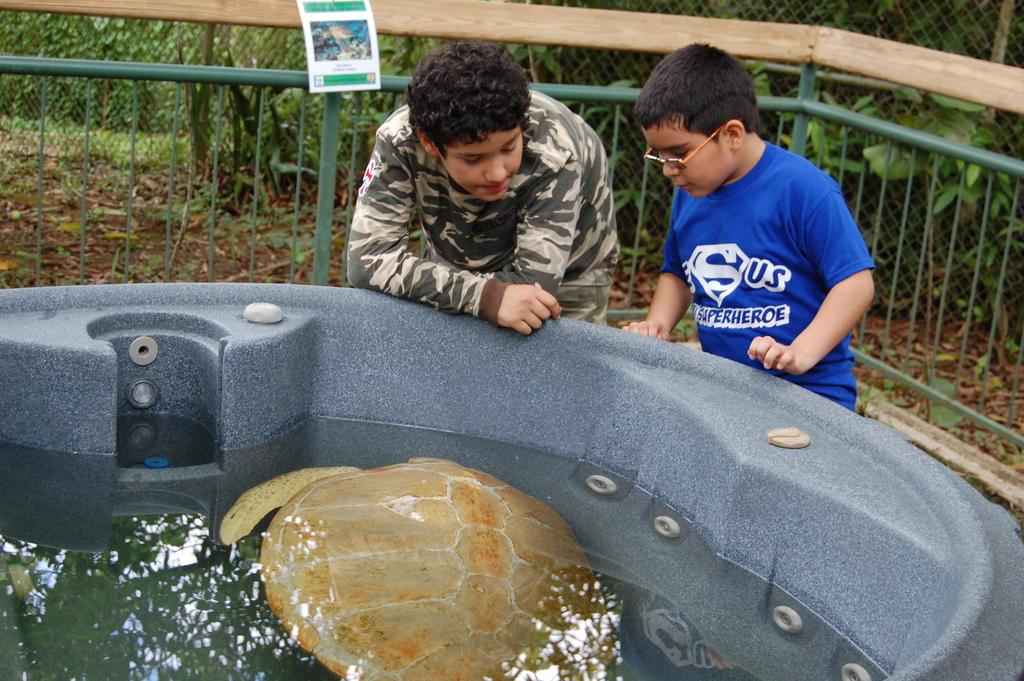What animal can be seen in the water in the image? There is a turtle in the water in the image. How many people are present in the image? There are two boys standing in the image. What type of vegetation is visible in the image? There are plants in the image. What type of structure can be seen in the image? There is an iron grille in the image. What object is made of paper in the image? There is a paper in the image. What type of barrier is present in the image? There is a fence in the image. Can you see a window in the image? There is no window present in the image. What type of vest is the turtle wearing in the image? There is no vest present in the image, as it features a turtle in the water and turtles do not wear clothing. 